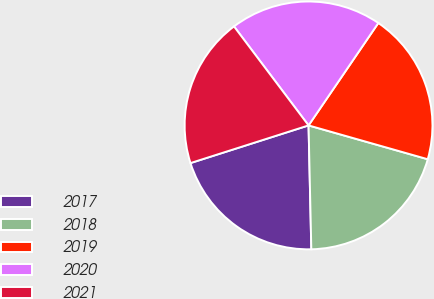Convert chart to OTSL. <chart><loc_0><loc_0><loc_500><loc_500><pie_chart><fcel>2017<fcel>2018<fcel>2019<fcel>2020<fcel>2021<nl><fcel>20.44%<fcel>20.24%<fcel>19.88%<fcel>19.79%<fcel>19.64%<nl></chart> 